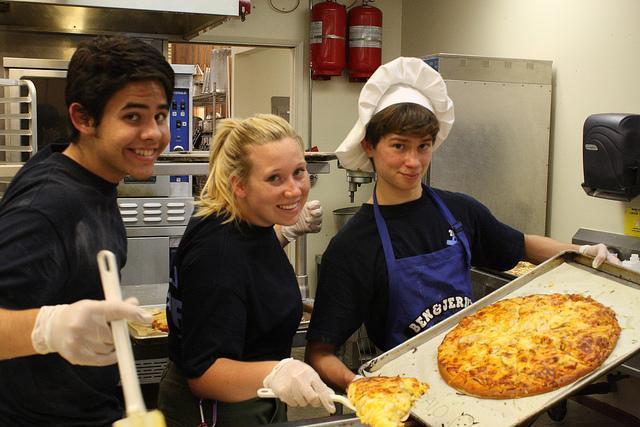How are the three people feeling in the kitchen?
Make your selection and explain in format: 'Answer: answer
Rationale: rationale.'
Options: Disappointed, angry, proud, hostile. Answer: proud.
Rationale: The three people are smiling and are showing off food. they are not angry, disappointed, or hostile. 